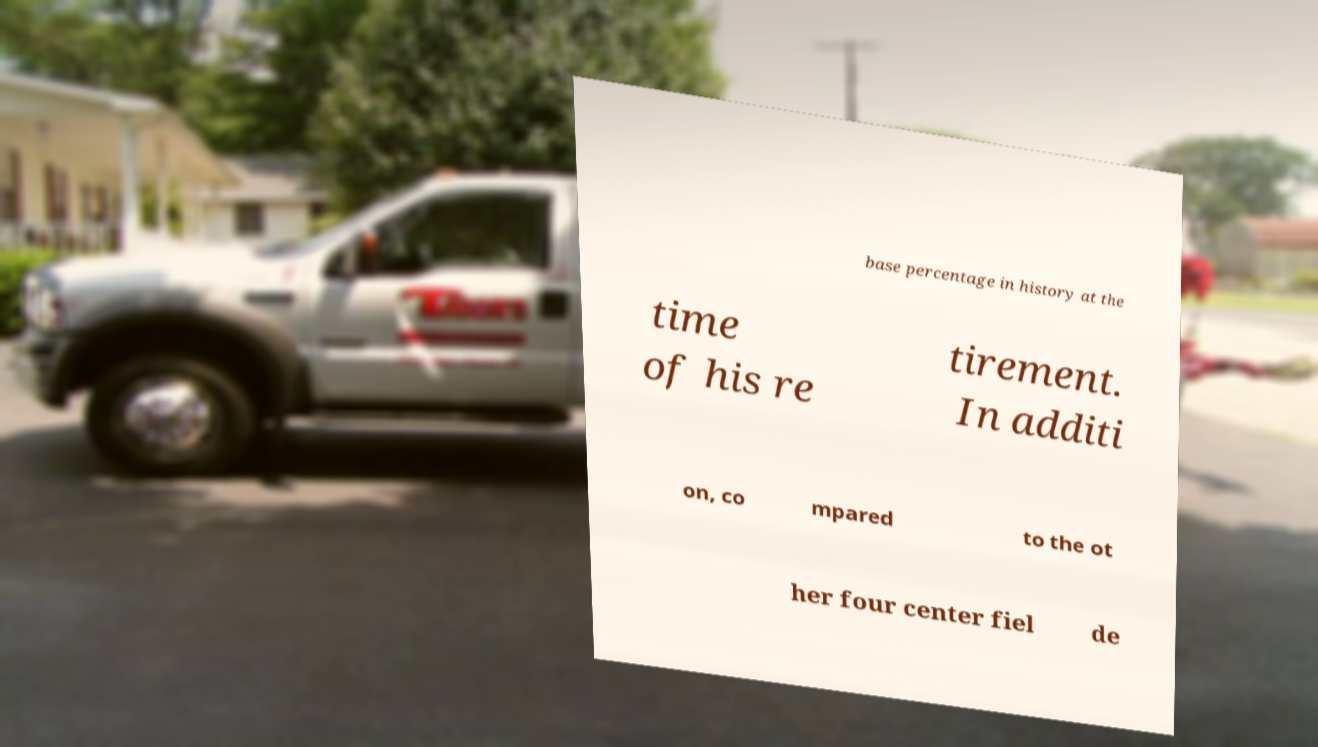Please identify and transcribe the text found in this image. base percentage in history at the time of his re tirement. In additi on, co mpared to the ot her four center fiel de 